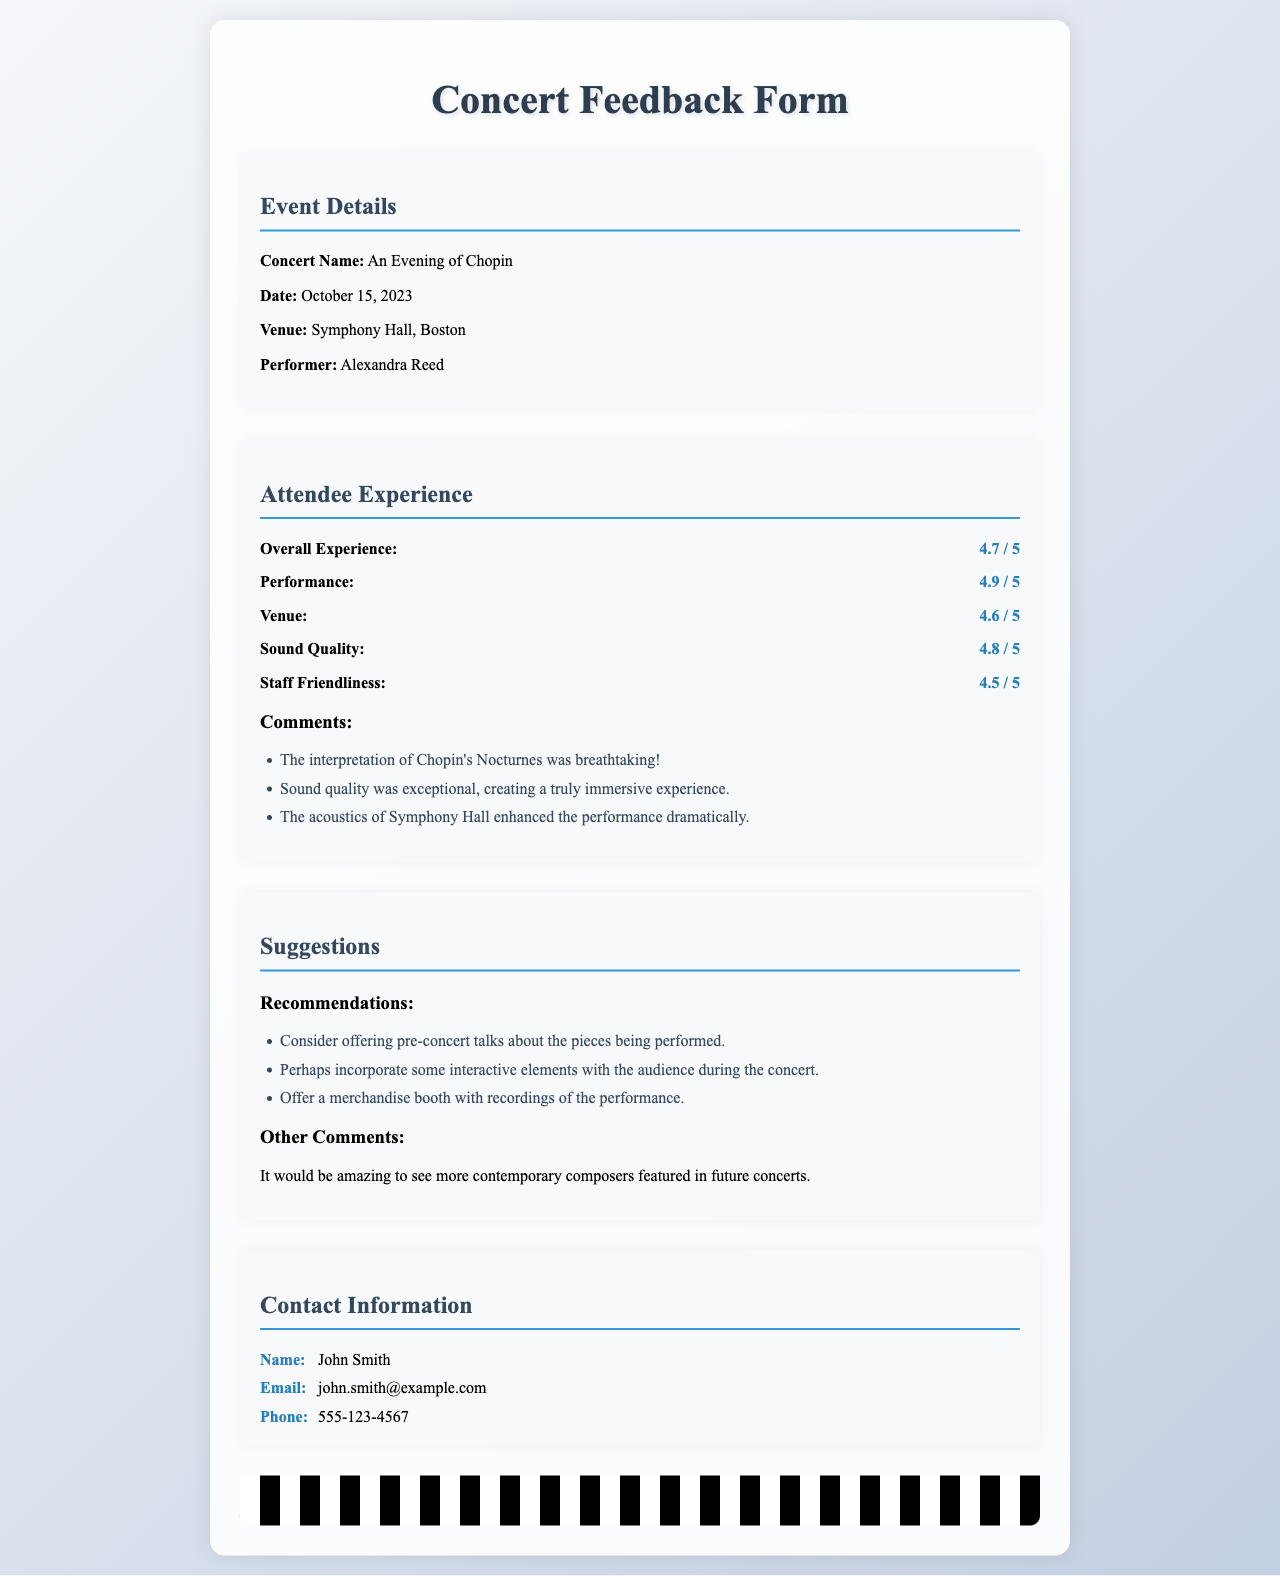What is the Concert Name? The Concert Name is stated in the document under Event Details.
Answer: An Evening of Chopin What is the date of the concert? The date is given in the Event Details section of the document.
Answer: October 15, 2023 What is the overall experience rating? The overall experience rating is located in the Attendee Experience section.
Answer: 4.7 / 5 What was noted about the sound quality? Comments section in the Attendee Experience mentions feedback about the sound quality.
Answer: Exceptional What is a suggestion made by the attendees? Suggestions section lists recommendations from attendees for improvements.
Answer: Offer pre-concert talks Who performed at the concert? The name of the performer is found in the Event Details part of the document.
Answer: Alexandra Reed What venue hosted the concert? The venue name is provided under Event Details in the document.
Answer: Symphony Hall, Boston What was the rating for Staff Friendliness? This rating is listed in the Attendee Experience section of the document.
Answer: 4.5 / 5 What is one of the other comments from attendees? The Other Comments section mentions additional thoughts from attendees.
Answer: More contemporary composers featured in future concerts 